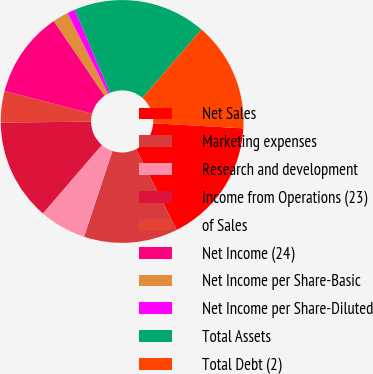Convert chart. <chart><loc_0><loc_0><loc_500><loc_500><pie_chart><fcel>Net Sales<fcel>Marketing expenses<fcel>Research and development<fcel>Income from Operations (23)<fcel>of Sales<fcel>Net Income (24)<fcel>Net Income per Share-Basic<fcel>Net Income per Share-Diluted<fcel>Total Assets<fcel>Total Debt (2)<nl><fcel>16.67%<fcel>12.5%<fcel>6.25%<fcel>13.54%<fcel>4.17%<fcel>11.46%<fcel>2.08%<fcel>1.04%<fcel>17.71%<fcel>14.58%<nl></chart> 